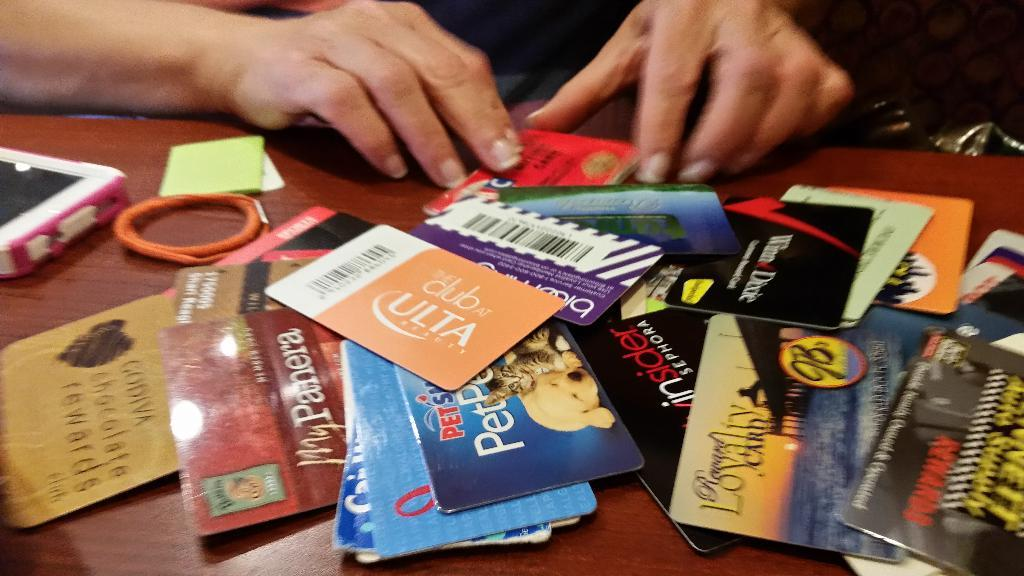Provide a one-sentence caption for the provided image. A pile of gift cards on a table, one to Club Ulta. 